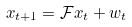<formula> <loc_0><loc_0><loc_500><loc_500>x _ { t + 1 } = \mathcal { F } x _ { t } + w _ { t }</formula> 